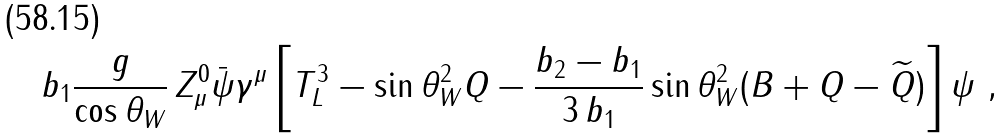<formula> <loc_0><loc_0><loc_500><loc_500>b _ { 1 } \frac { g } { \cos \theta _ { W } } \, Z _ { \mu } ^ { 0 } \bar { \psi } \gamma ^ { \mu } \left [ T _ { L } ^ { 3 } - \sin \theta _ { W } ^ { 2 } Q - \frac { b _ { 2 } - b _ { 1 } } { 3 \, b _ { 1 } } \sin \theta _ { W } ^ { 2 } ( B + Q - \widetilde { Q } ) \right ] \psi \ ,</formula> 